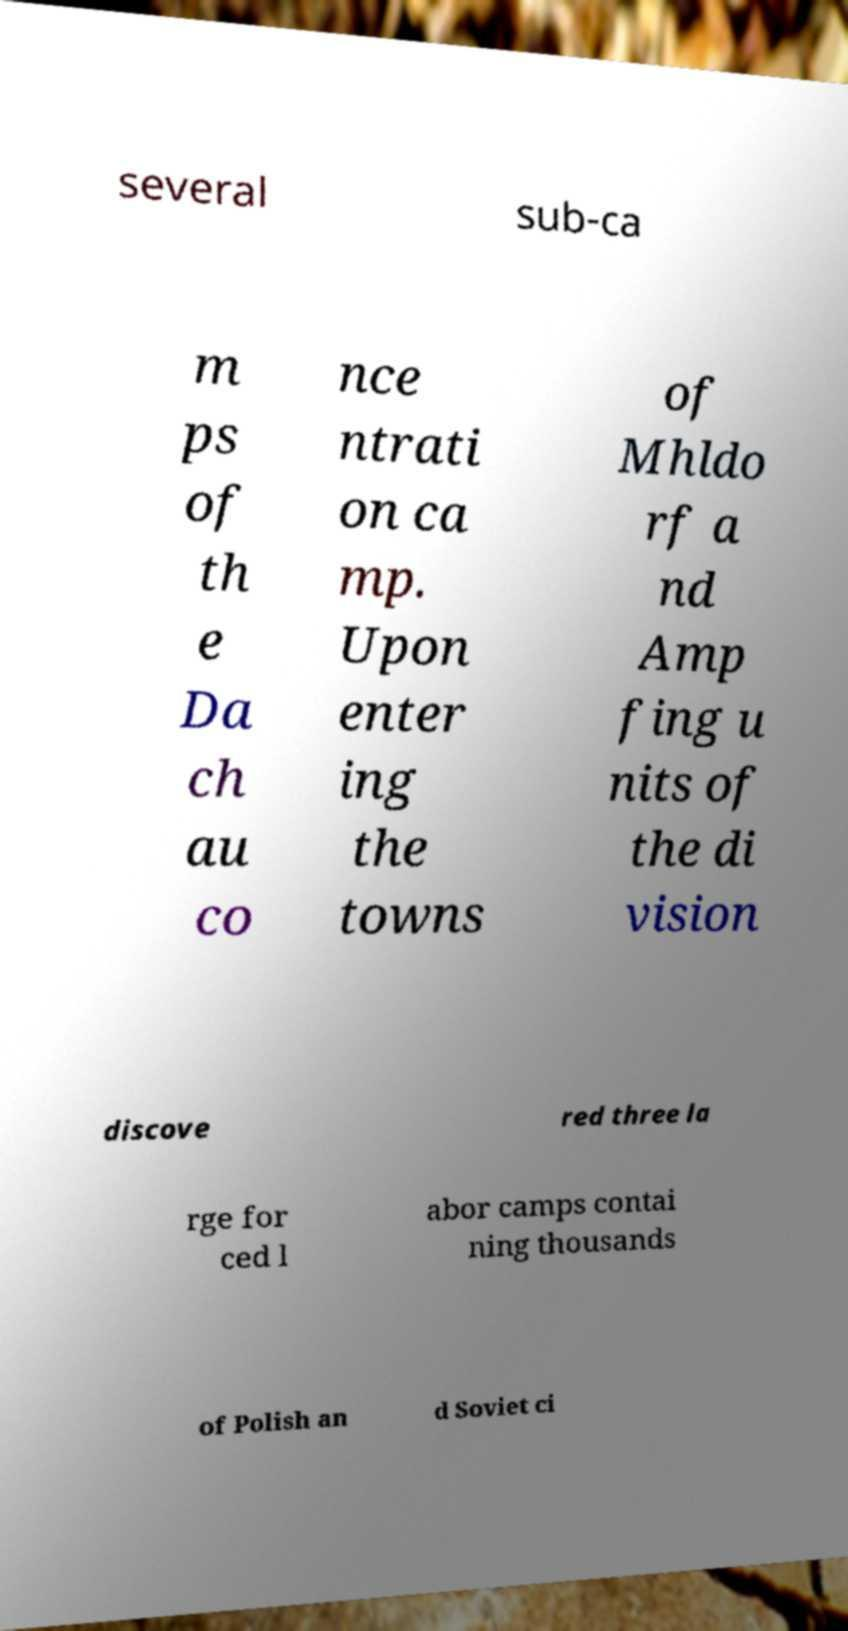There's text embedded in this image that I need extracted. Can you transcribe it verbatim? several sub-ca m ps of th e Da ch au co nce ntrati on ca mp. Upon enter ing the towns of Mhldo rf a nd Amp fing u nits of the di vision discove red three la rge for ced l abor camps contai ning thousands of Polish an d Soviet ci 